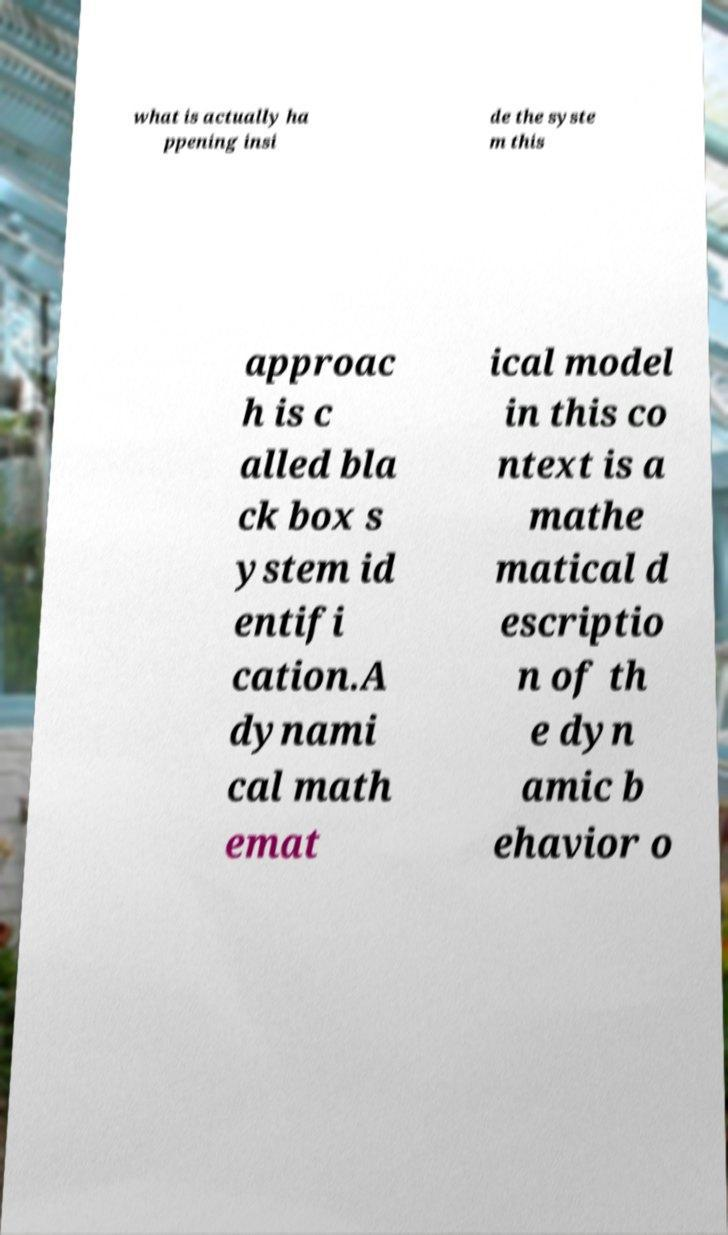Could you extract and type out the text from this image? what is actually ha ppening insi de the syste m this approac h is c alled bla ck box s ystem id entifi cation.A dynami cal math emat ical model in this co ntext is a mathe matical d escriptio n of th e dyn amic b ehavior o 